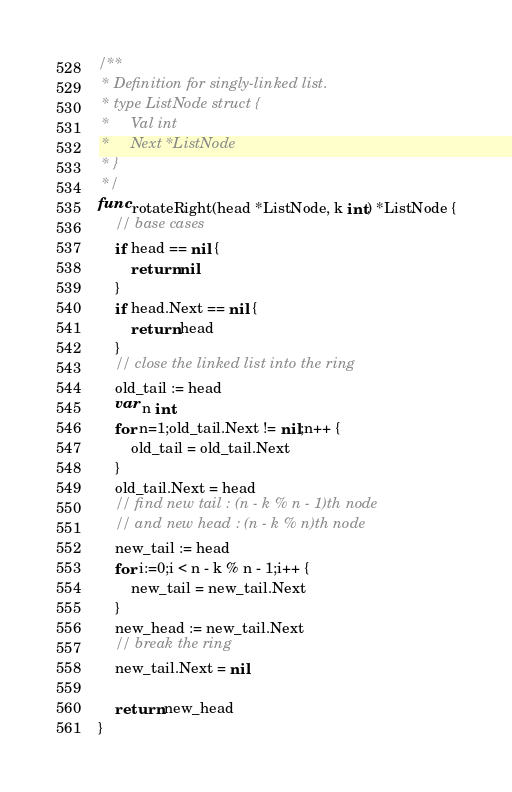<code> <loc_0><loc_0><loc_500><loc_500><_Go_>/**
 * Definition for singly-linked list.
 * type ListNode struct {
 *     Val int
 *     Next *ListNode
 * }
 */
func rotateRight(head *ListNode, k int) *ListNode {
    // base cases
    if head == nil {
        return nil
    }
    if head.Next == nil {
        return head
    }
    // close the linked list into the ring
    old_tail := head
    var n int
    for n=1;old_tail.Next != nil;n++ {
        old_tail = old_tail.Next
    }
    old_tail.Next = head
    // find new tail : (n - k % n - 1)th node
    // and new head : (n - k % n)th node
    new_tail := head
    for i:=0;i < n - k % n - 1;i++ {
        new_tail = new_tail.Next
    }
    new_head := new_tail.Next
    // break the ring
    new_tail.Next = nil

    return new_head
}
</code> 